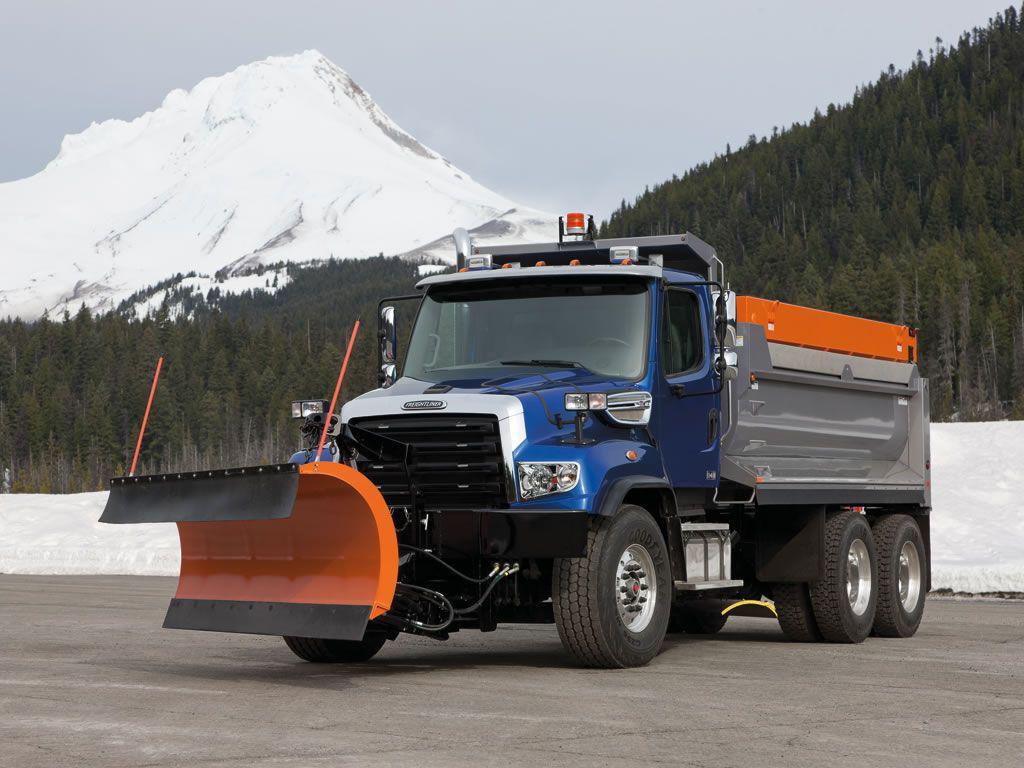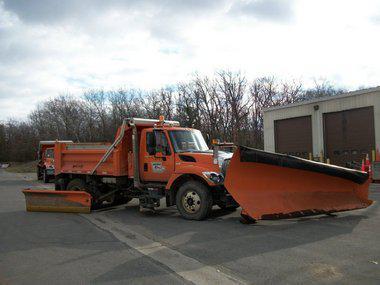The first image is the image on the left, the second image is the image on the right. Examine the images to the left and right. Is the description "One snow plow is plowing snow." accurate? Answer yes or no. No. 